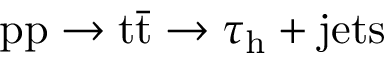Convert formula to latex. <formula><loc_0><loc_0><loc_500><loc_500>p p \rightarrow t \bar { t } \rightarrow \tau _ { h } + j e t s</formula> 